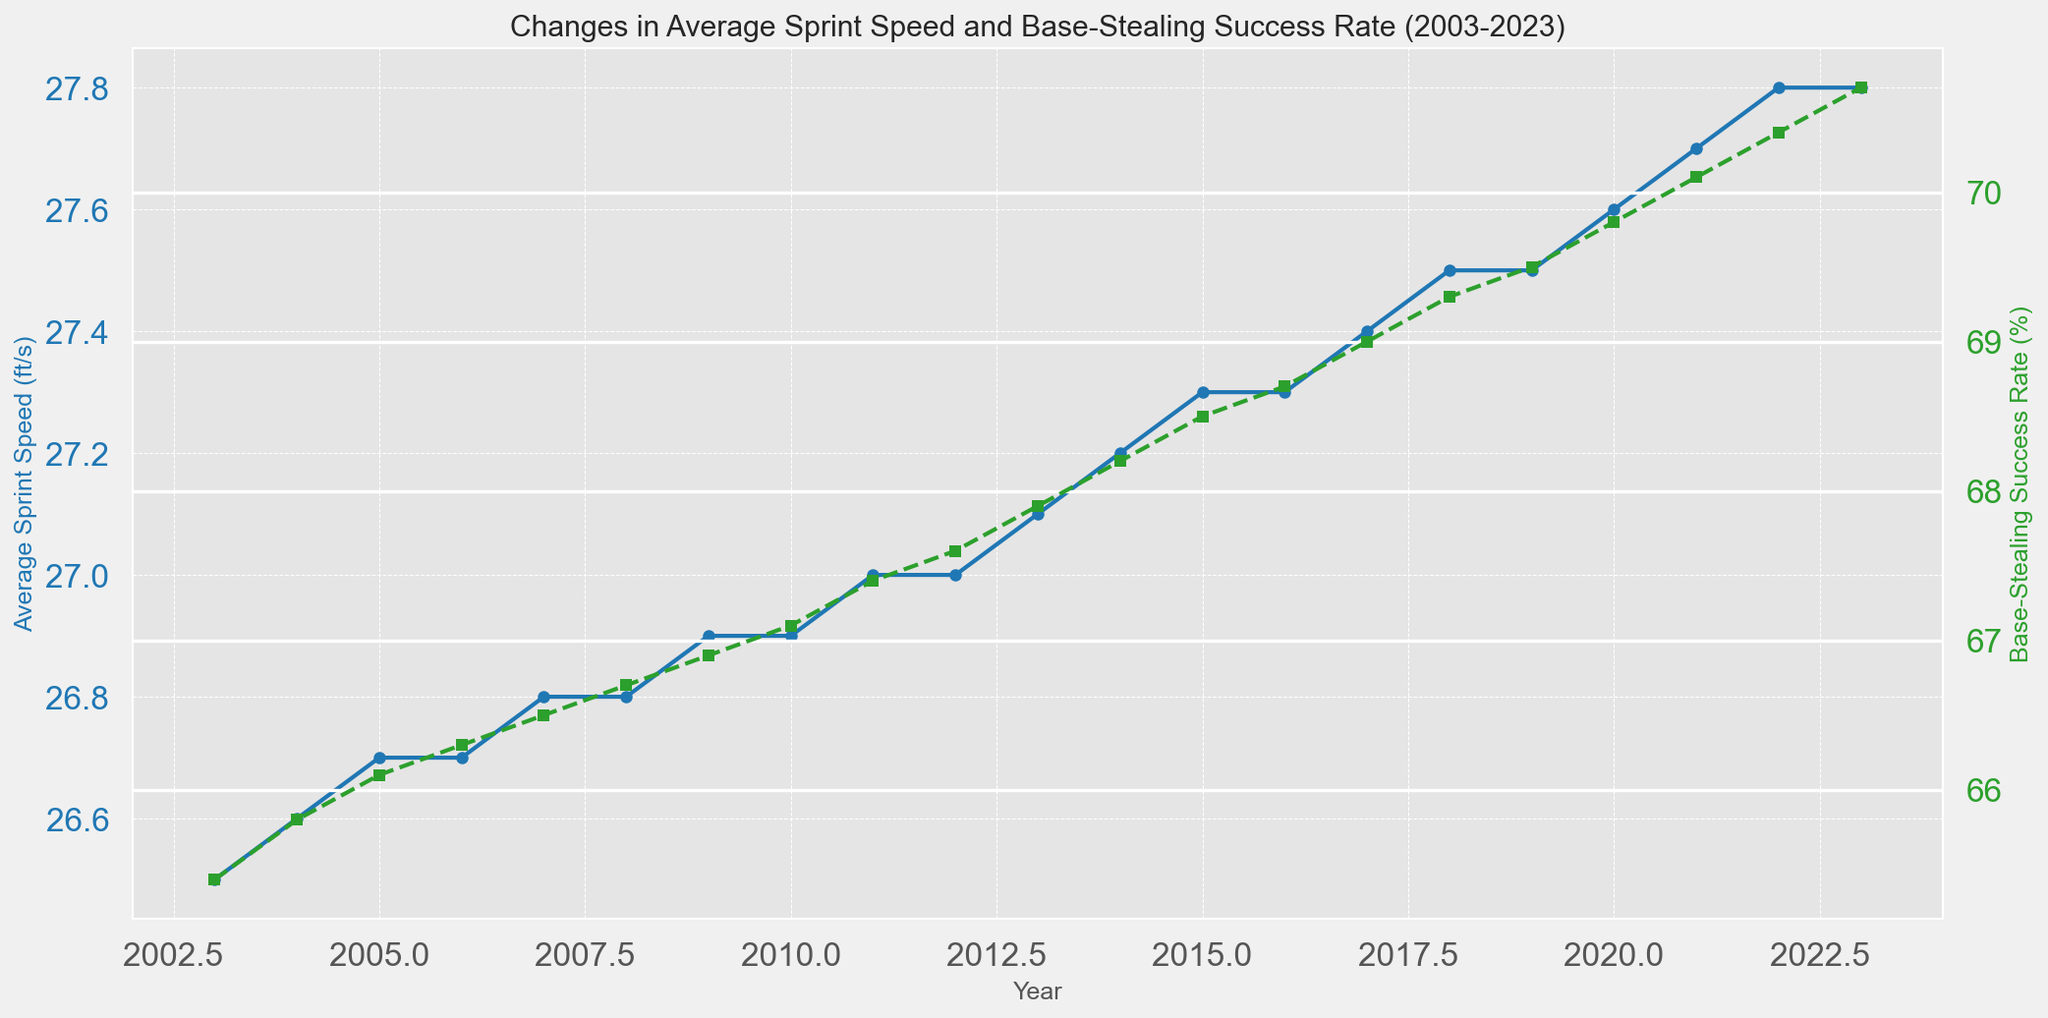What is the trend in average sprint speed from 2003 to 2023? The blue line in the plot shows a steady increase in average sprint speed over the years from 26.5 ft/s in 2003 to 27.8 ft/s in 2023.
Answer: Steady increase Which year witnessed the highest base-stealing success rate? The green line in the plot indicates that 2023 has the highest base-stealing success rate at 70.7%.
Answer: 2023 What is the difference in base-stealing success rate between 2003 and 2023? In 2003, the success rate was 65.4%, and in 2023, it is 70.7%. The difference is calculated as 70.7% - 65.4%.
Answer: 5.3% How did the sprint speed change between 2015 and 2020? The blue line indicates that sprint speed increased from 27.3 ft/s in 2015 to 27.6 ft/s in 2020 which is a total increase of 0.3 ft/s.
Answer: Increase by 0.3 ft/s During which period did the base-stealing success rate surpass 70%? The green line shows that the success rate surpassed 70% starting from 2021 onwards.
Answer: 2021 onwards Compare the sprint speed and base-stealing success rate trends from 2010 to 2015. The plot shows that from 2010 to 2015, both sprint speed and base-stealing success rate gradually increased. Sprint speed increased from 26.9 ft/s to 27.3 ft/s, and success rate increased from 67.1% to 68.5%.
Answer: Both increased What can you deduce about the relationship between sprint speed and base-stealing success rate across the years? Both metrics have increased over the years, suggesting a positive correlation where increased sprint speed is associated with higher base-stealing success rates.
Answer: Positive correlation Between which two consecutive years was there the largest increase in sprint speed? By inspecting the blue line, the largest increase in sprint speed occurred between the years 2021 and 2022, where it increased from 27.7 ft/s to 27.8 ft/s.
Answer: 2021 and 2022 What is the average sprint speed from 2003 to 2023? To calculate the average sprint speed, sum all sprint speeds and divide by the number of years: (26.5 + 26.6 + 26.7 + 26.7 + 26.8 + 26.8 + 26.9 + 26.9 + 27.0 + 27.0 + 27.1 + 27.2 + 27.3 + 27.3 + 27.4 + 27.5 + 27.5 + 27.6 + 27.7 + 27.8 + 27.8) / 21 = 27.10 ft/s.
Answer: 27.10 ft/s What visual cues show changes in base-stealing success rates over the years? The green line with square markers on the plot clearly depicts changes in base-stealing success rates across the years, showing an upward trend.
Answer: Green line with square markers 